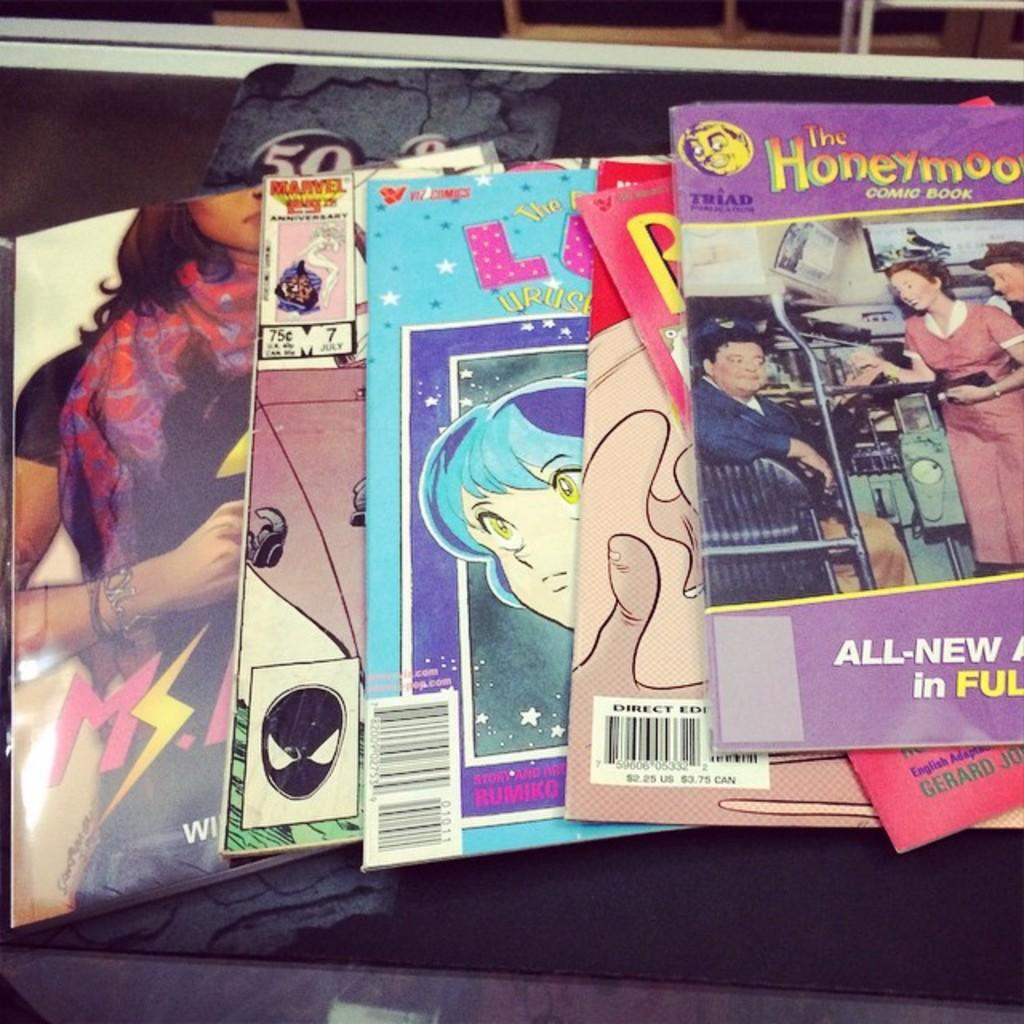<image>
Relay a brief, clear account of the picture shown. A few magazines in a row with one titled The Honeymooners. 